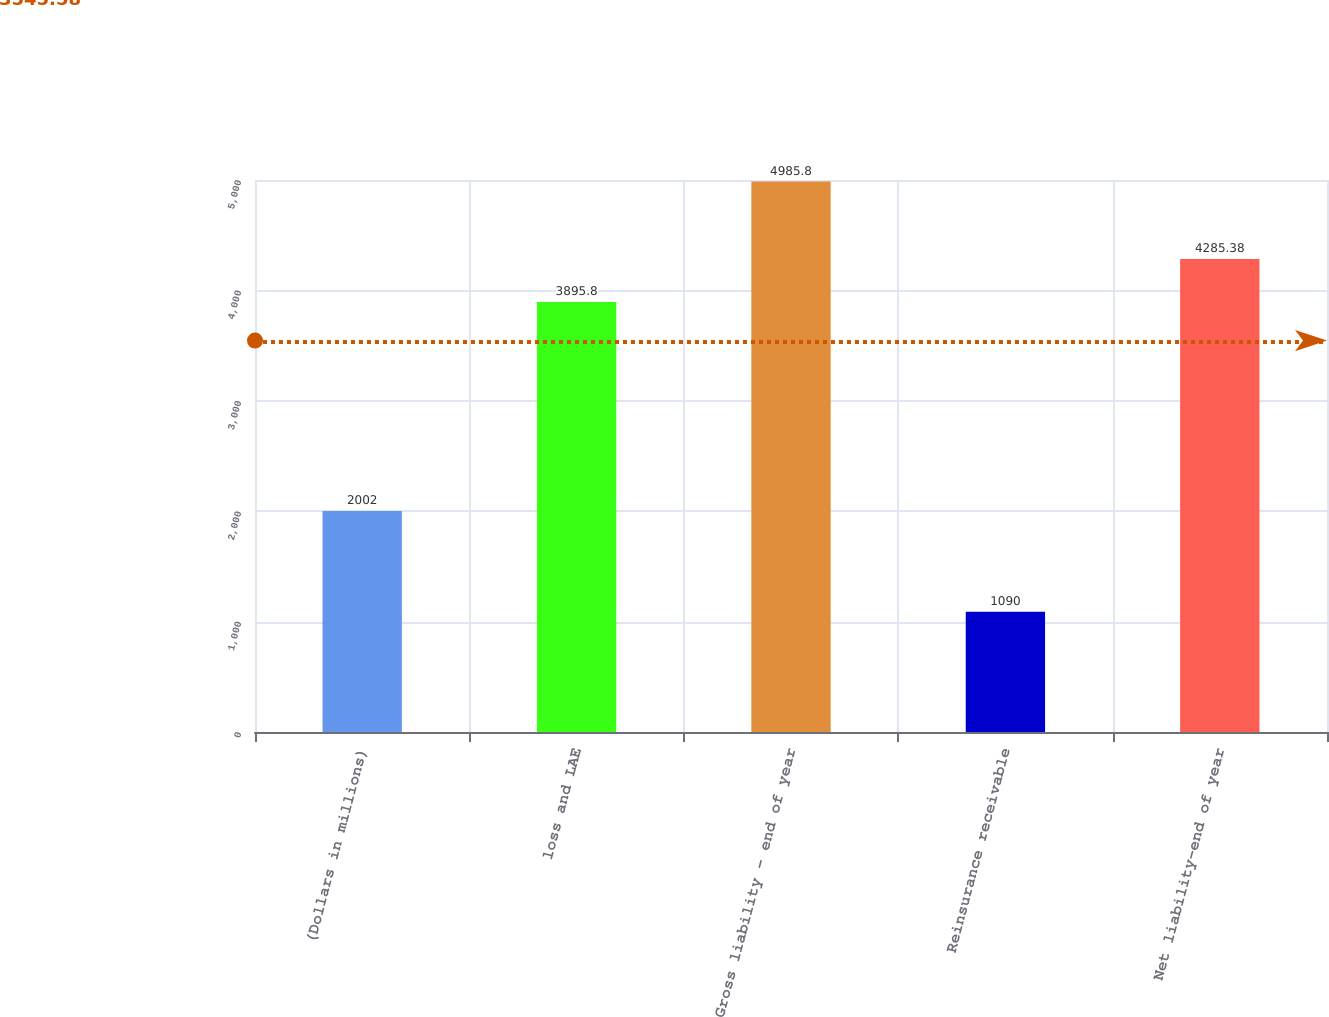Convert chart to OTSL. <chart><loc_0><loc_0><loc_500><loc_500><bar_chart><fcel>(Dollars in millions)<fcel>loss and LAE<fcel>Gross liability - end of year<fcel>Reinsurance receivable<fcel>Net liability-end of year<nl><fcel>2002<fcel>3895.8<fcel>4985.8<fcel>1090<fcel>4285.38<nl></chart> 